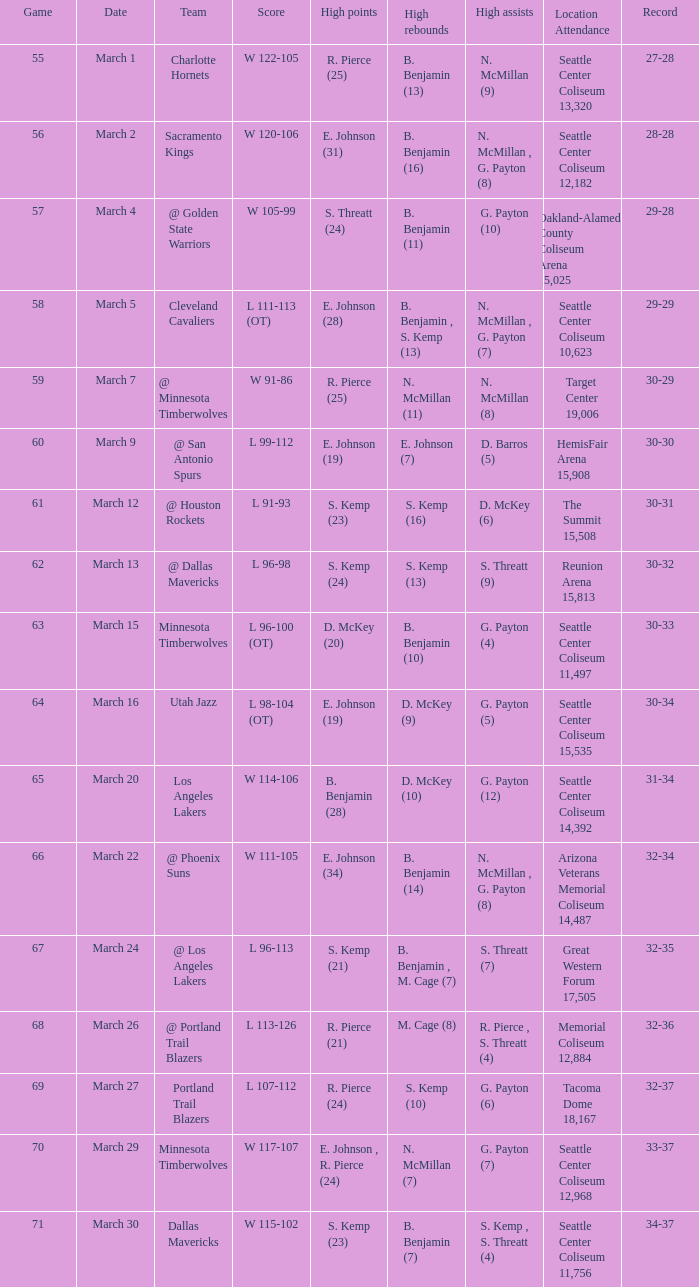Which Game has a Team of portland trail blazers? 69.0. 